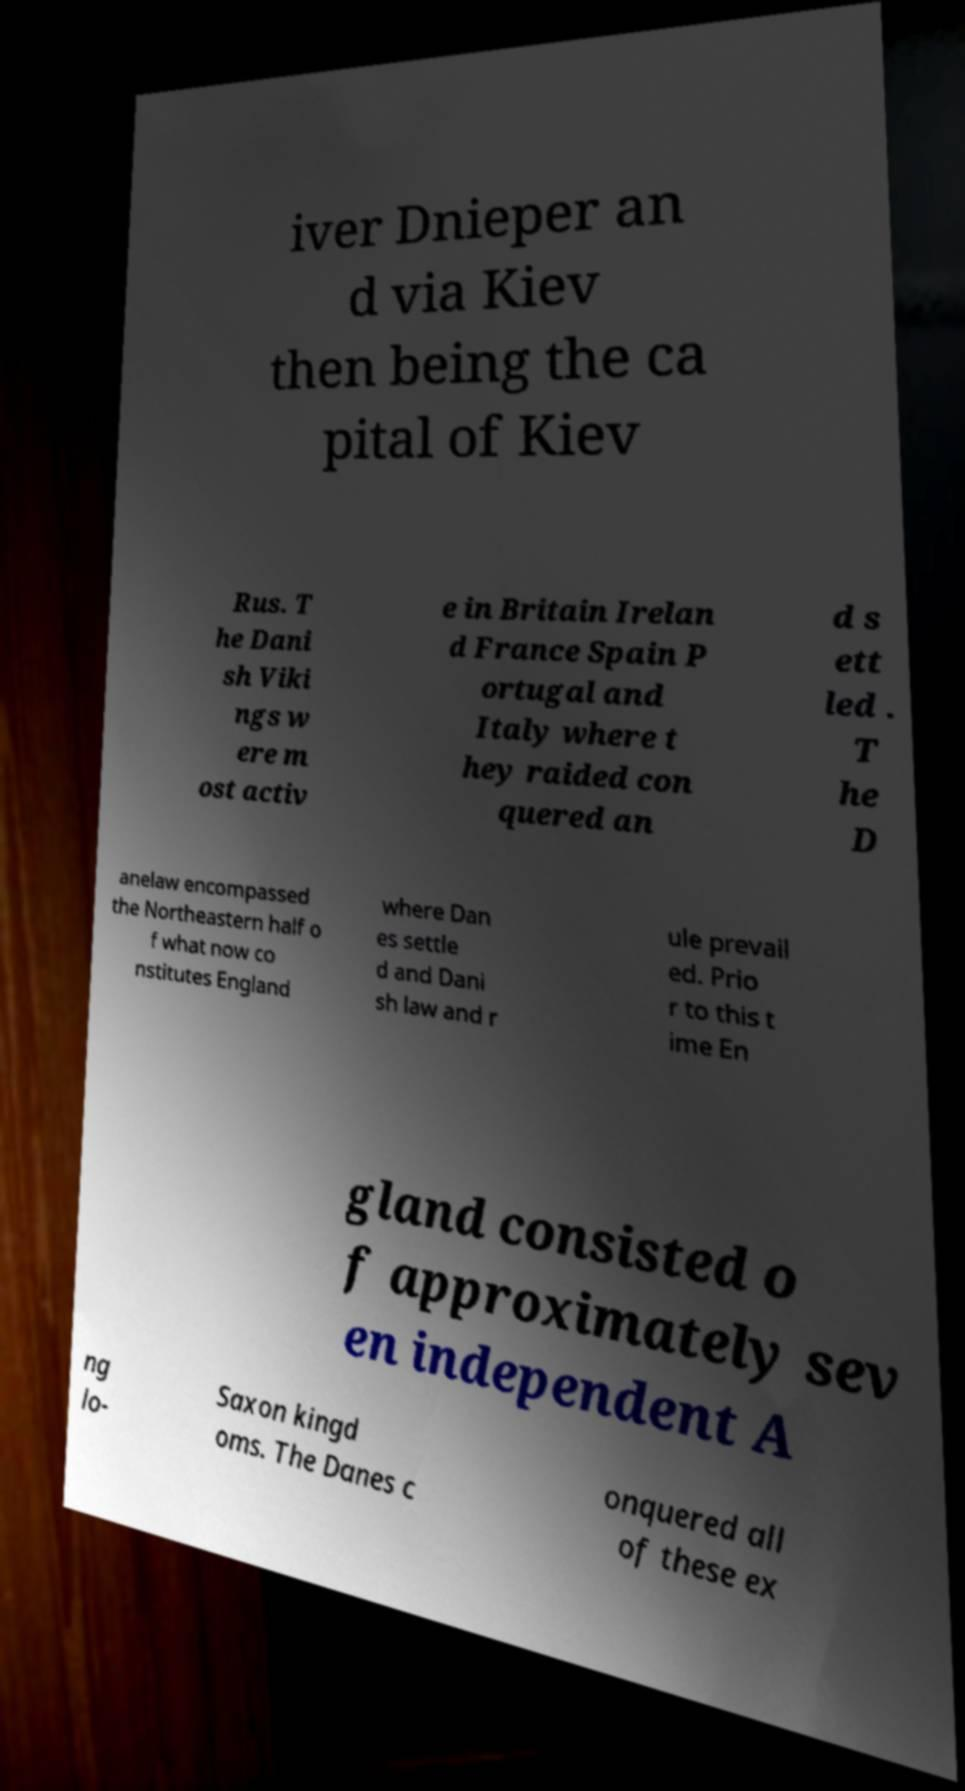What messages or text are displayed in this image? I need them in a readable, typed format. iver Dnieper an d via Kiev then being the ca pital of Kiev Rus. T he Dani sh Viki ngs w ere m ost activ e in Britain Irelan d France Spain P ortugal and Italy where t hey raided con quered an d s ett led . T he D anelaw encompassed the Northeastern half o f what now co nstitutes England where Dan es settle d and Dani sh law and r ule prevail ed. Prio r to this t ime En gland consisted o f approximately sev en independent A ng lo- Saxon kingd oms. The Danes c onquered all of these ex 